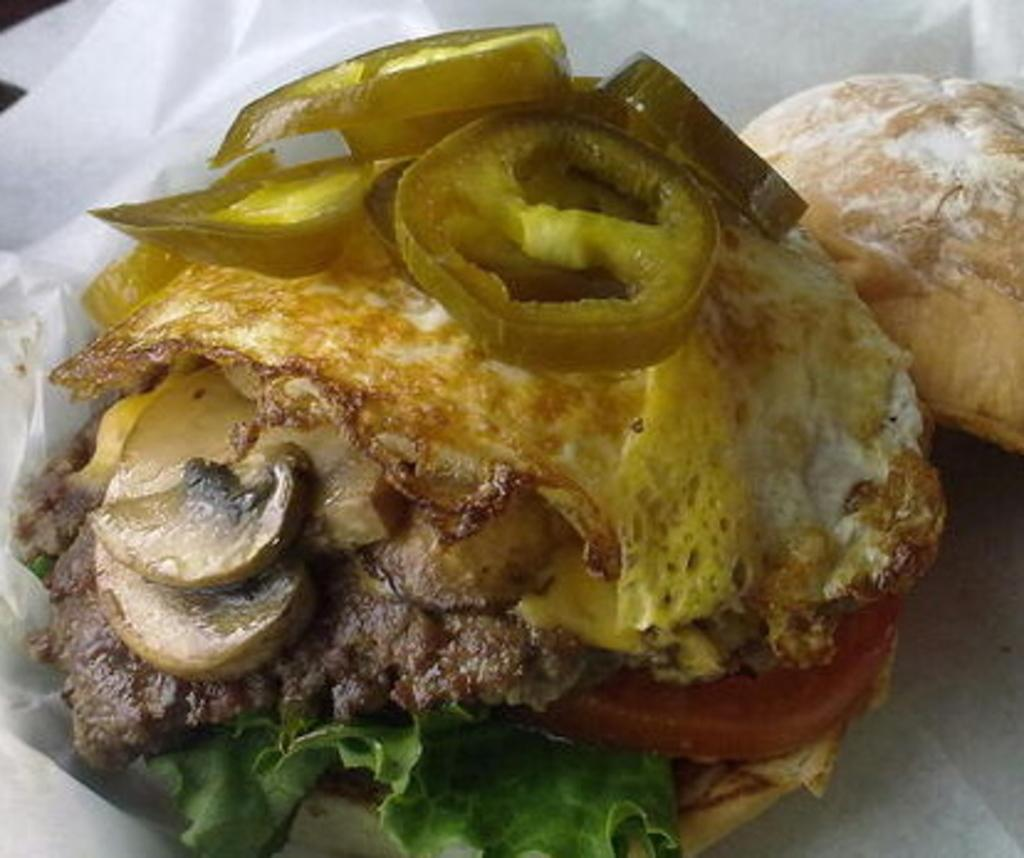What type of food is the main subject of the image? There is an omelette in the image. What ingredients can be seen in the omelette? Jalapenos are visible in the omelette. What type of bread is present in the image? There is a slice of bread in the image. What type of vegetable is included in the image? There is green salad in the image. What type of meat is present in the image? There are slices of bacon in the image. What other ingredient can be seen in the image? Chopped mushrooms are present in the image. What type of hat is the person wearing in the image? There is no person wearing a hat in the image; it features food items only. Is there any indication of a fight or conflict in the image? No, there is no indication of a fight or conflict in the image; it features food items only. 